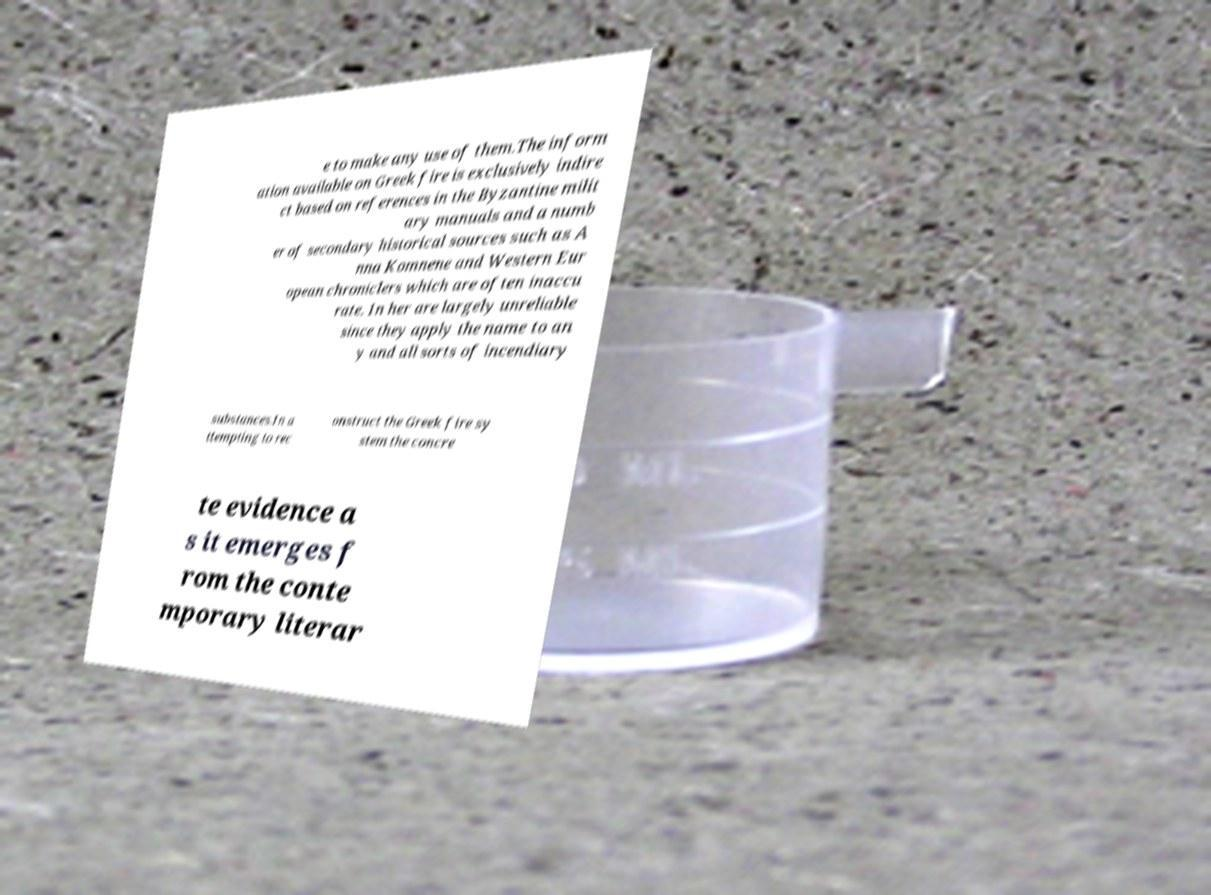Can you accurately transcribe the text from the provided image for me? e to make any use of them.The inform ation available on Greek fire is exclusively indire ct based on references in the Byzantine milit ary manuals and a numb er of secondary historical sources such as A nna Komnene and Western Eur opean chroniclers which are often inaccu rate. In her are largely unreliable since they apply the name to an y and all sorts of incendiary substances.In a ttempting to rec onstruct the Greek fire sy stem the concre te evidence a s it emerges f rom the conte mporary literar 